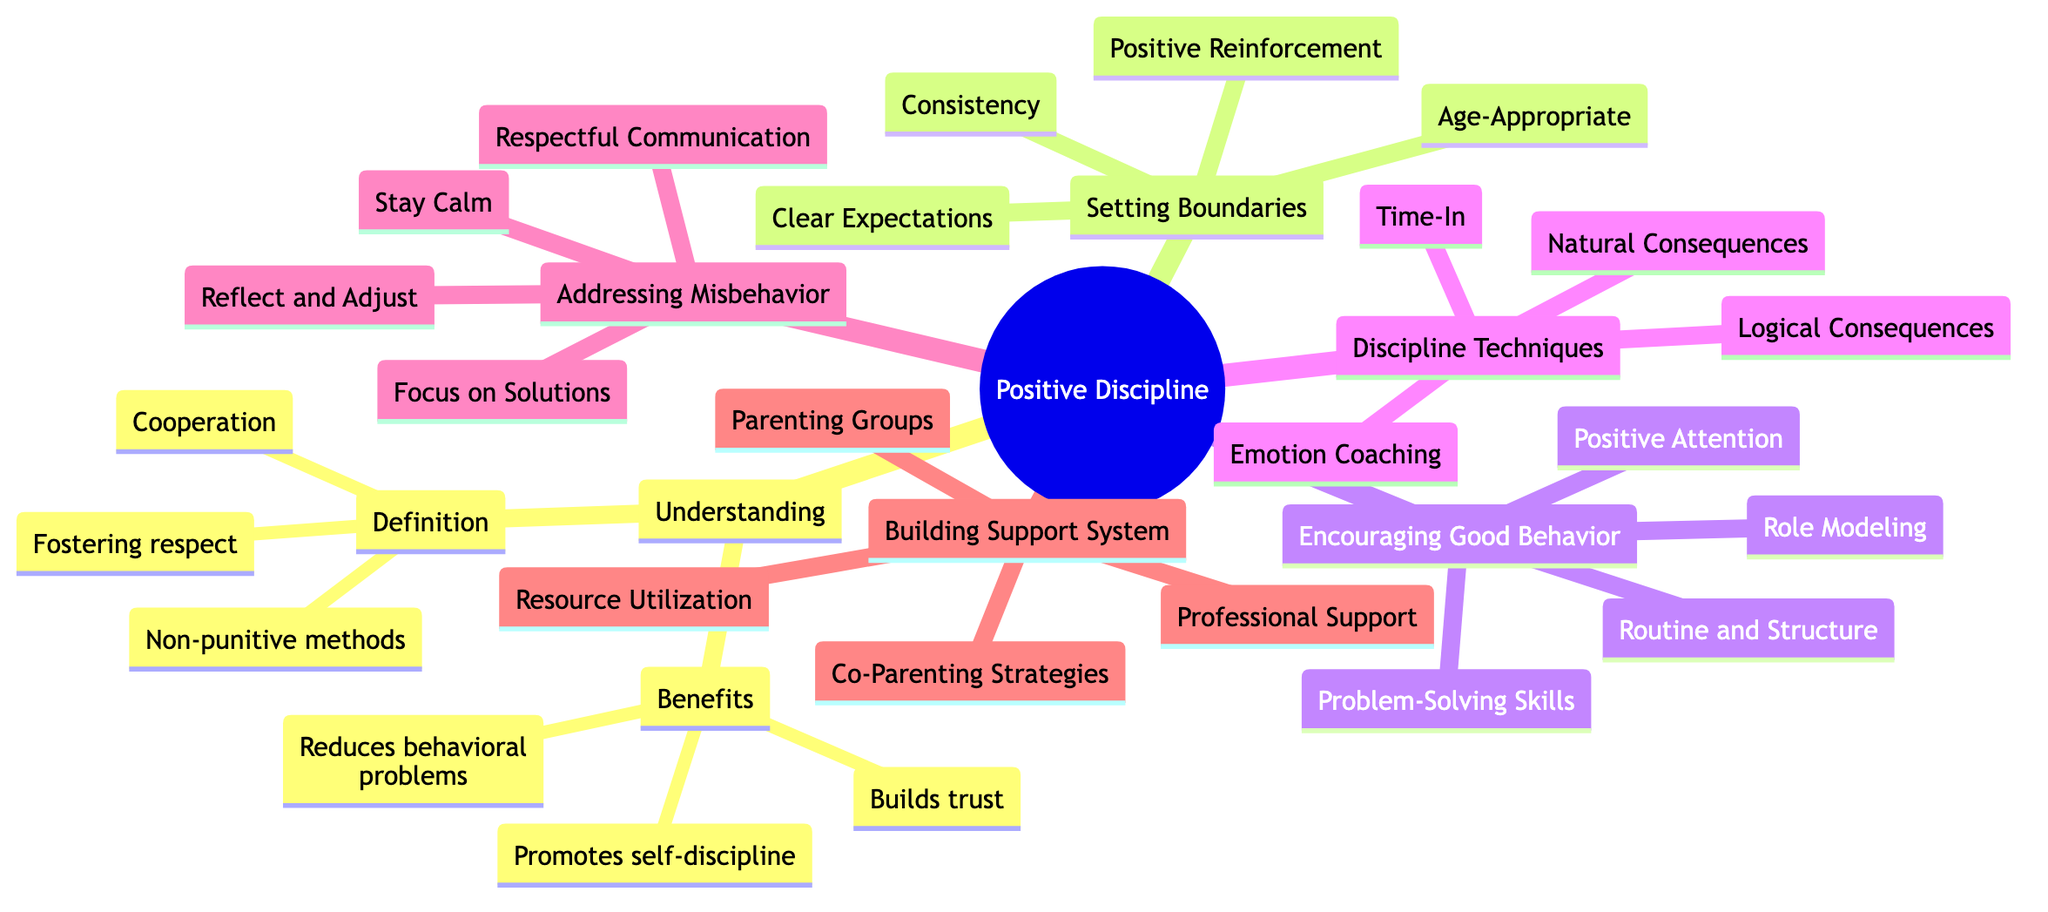What is the definition of Positive Discipline? The definition can be found under "Understanding Positive Discipline" in the diagram, which states that it is about fostering respect, cooperation, and good behavior through non-punitive methods.
Answer: Fostering respect, cooperation, and good behavior through non-punitive methods What are the benefits of Positive Discipline? The diagram lists benefits under "Understanding Positive Discipline", which include building trust between parent and child, promoting self-discipline in children, and reducing behavioral problems long-term.
Answer: Builds trust, promotes self-discipline, reduces behavioral problems What is a technique listed under "Discipline Techniques"? The "Discipline Techniques" node includes various techniques, one of which is "Time-In." This is a method used in positive discipline approaches.
Answer: Time-In How many techniques are listed under "Discipline Techniques"? The node under "Discipline Techniques" has four sub-nodes listed: Time-In, Natural Consequences, Logical Consequences, and Emotion Coaching. Hence, there are four techniques.
Answer: 4 What does "Positive Reinforcement" refer to in the context of boundaries? "Positive Reinforcement" is categorized under "Setting Boundaries" and specifically refers to praising and rewarding compliance with established rules and boundaries.
Answer: Praise and reward compliance What approach should parents adopt when addressing misbehavior? The diagram suggests several approaches under "Addressing Misbehavior"; one key recommendation is to "Stay Calm" when addressing issues to maintain composure.
Answer: Stay Calm How does building a support system help in positive discipline? The "Building a Support System" section emphasizes strategies such as co-parenting and joining parenting groups to share experiences and tips, which can lead to more consistent and effective discipline.
Answer: Consistent discipline approaches What is one component of "Encouraging Good Behavior"? One of the components listed under "Encouraging Good Behavior" is "Role Modeling," which signifies demonstrating desired behaviors for children to emulate.
Answer: Role Modeling Which aspect of discipline emphasizes natural outcomes of children’s actions? The technique referred to is "Natural Consequences," which is designed to allow children to experience the outcomes of their actions naturally.
Answer: Natural Consequences 